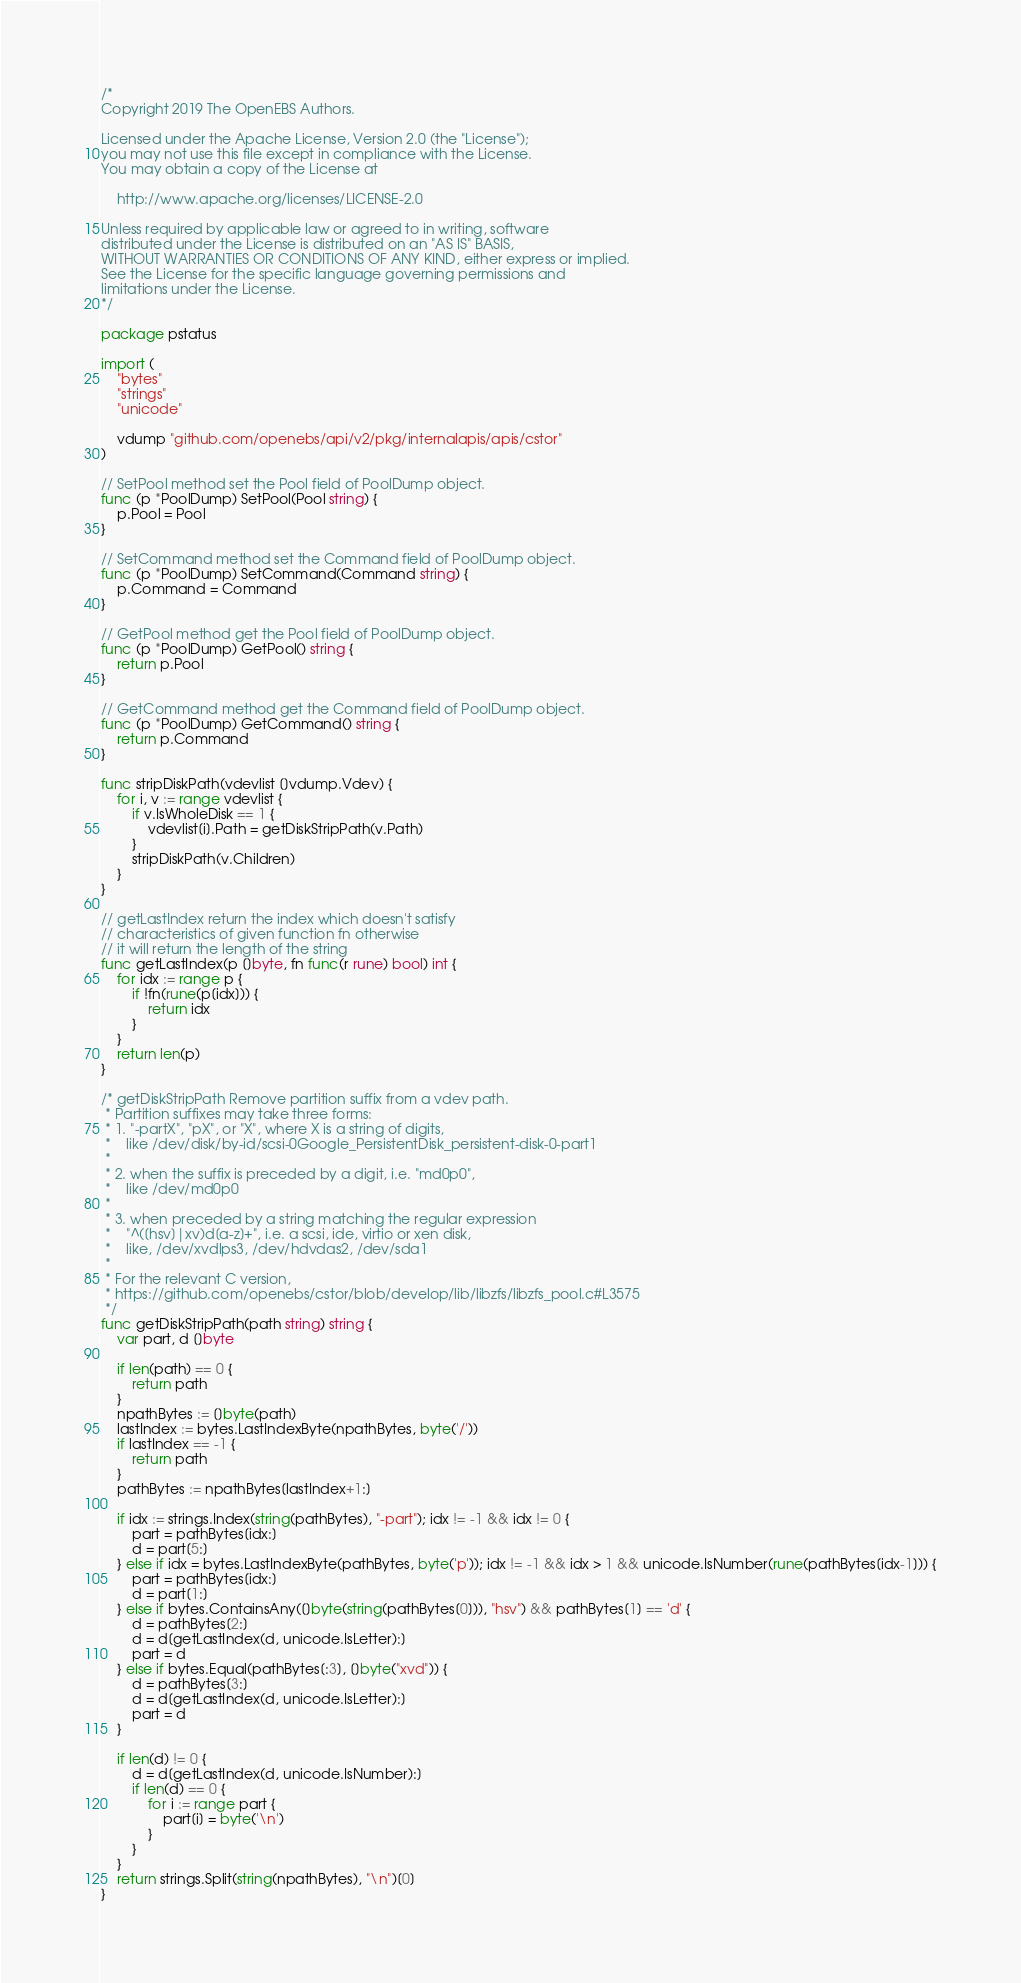<code> <loc_0><loc_0><loc_500><loc_500><_Go_>/*
Copyright 2019 The OpenEBS Authors.

Licensed under the Apache License, Version 2.0 (the "License");
you may not use this file except in compliance with the License.
You may obtain a copy of the License at

    http://www.apache.org/licenses/LICENSE-2.0

Unless required by applicable law or agreed to in writing, software
distributed under the License is distributed on an "AS IS" BASIS,
WITHOUT WARRANTIES OR CONDITIONS OF ANY KIND, either express or implied.
See the License for the specific language governing permissions and
limitations under the License.
*/

package pstatus

import (
	"bytes"
	"strings"
	"unicode"

	vdump "github.com/openebs/api/v2/pkg/internalapis/apis/cstor"
)

// SetPool method set the Pool field of PoolDump object.
func (p *PoolDump) SetPool(Pool string) {
	p.Pool = Pool
}

// SetCommand method set the Command field of PoolDump object.
func (p *PoolDump) SetCommand(Command string) {
	p.Command = Command
}

// GetPool method get the Pool field of PoolDump object.
func (p *PoolDump) GetPool() string {
	return p.Pool
}

// GetCommand method get the Command field of PoolDump object.
func (p *PoolDump) GetCommand() string {
	return p.Command
}

func stripDiskPath(vdevlist []vdump.Vdev) {
	for i, v := range vdevlist {
		if v.IsWholeDisk == 1 {
			vdevlist[i].Path = getDiskStripPath(v.Path)
		}
		stripDiskPath(v.Children)
	}
}

// getLastIndex return the index which doesn't satisfy
// characteristics of given function fn otherwise
// it will return the length of the string
func getLastIndex(p []byte, fn func(r rune) bool) int {
	for idx := range p {
		if !fn(rune(p[idx])) {
			return idx
		}
	}
	return len(p)
}

/* getDiskStripPath Remove partition suffix from a vdev path.
 * Partition suffixes may take three forms:
 * 1. "-partX", "pX", or "X", where X is a string of digits,
 *    like /dev/disk/by-id/scsi-0Google_PersistentDisk_persistent-disk-0-part1
 *
 * 2. when the suffix is preceded by a digit, i.e. "md0p0",
 *    like /dev/md0p0
 *
 * 3. when preceded by a string matching the regular expression
 *    "^([hsv]|xv)d[a-z]+", i.e. a scsi, ide, virtio or xen disk,
 *    like, /dev/xvdlps3, /dev/hdvdas2, /dev/sda1
 *
 * For the relevant C version,
 * https://github.com/openebs/cstor/blob/develop/lib/libzfs/libzfs_pool.c#L3575
 */
func getDiskStripPath(path string) string {
	var part, d []byte

	if len(path) == 0 {
		return path
	}
	npathBytes := []byte(path)
	lastIndex := bytes.LastIndexByte(npathBytes, byte('/'))
	if lastIndex == -1 {
		return path
	}
	pathBytes := npathBytes[lastIndex+1:]

	if idx := strings.Index(string(pathBytes), "-part"); idx != -1 && idx != 0 {
		part = pathBytes[idx:]
		d = part[5:]
	} else if idx = bytes.LastIndexByte(pathBytes, byte('p')); idx != -1 && idx > 1 && unicode.IsNumber(rune(pathBytes[idx-1])) {
		part = pathBytes[idx:]
		d = part[1:]
	} else if bytes.ContainsAny([]byte(string(pathBytes[0])), "hsv") && pathBytes[1] == 'd' {
		d = pathBytes[2:]
		d = d[getLastIndex(d, unicode.IsLetter):]
		part = d
	} else if bytes.Equal(pathBytes[:3], []byte("xvd")) {
		d = pathBytes[3:]
		d = d[getLastIndex(d, unicode.IsLetter):]
		part = d
	}

	if len(d) != 0 {
		d = d[getLastIndex(d, unicode.IsNumber):]
		if len(d) == 0 {
			for i := range part {
				part[i] = byte('\n')
			}
		}
	}
	return strings.Split(string(npathBytes), "\n")[0]
}
</code> 